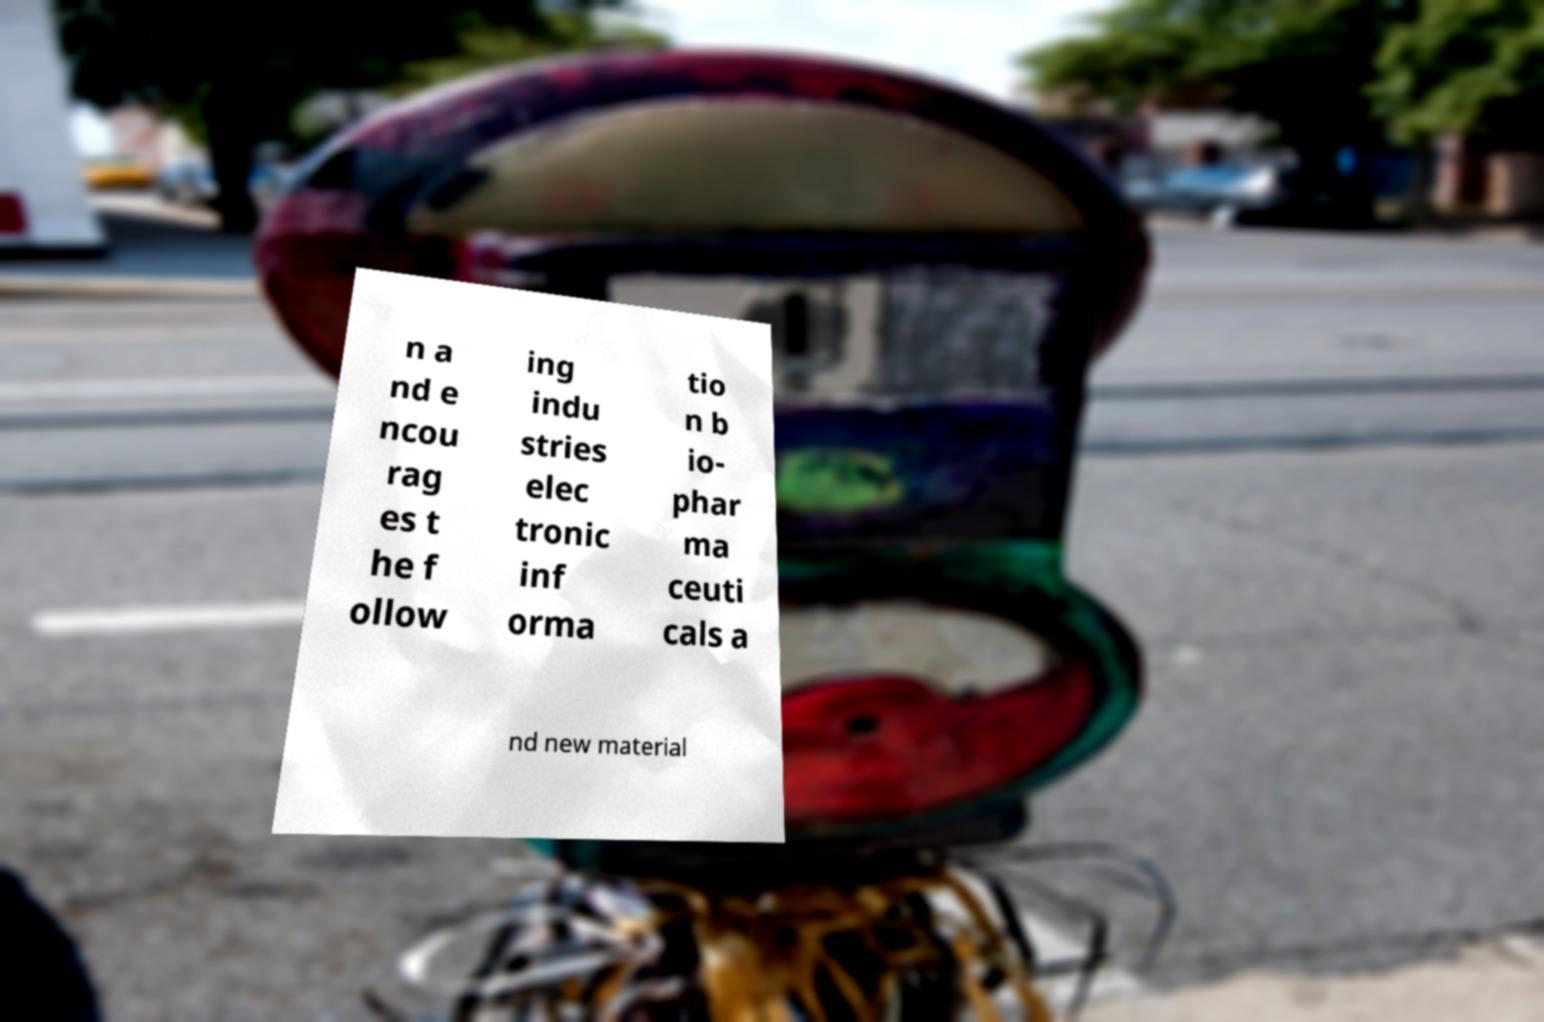Can you read and provide the text displayed in the image?This photo seems to have some interesting text. Can you extract and type it out for me? n a nd e ncou rag es t he f ollow ing indu stries elec tronic inf orma tio n b io- phar ma ceuti cals a nd new material 